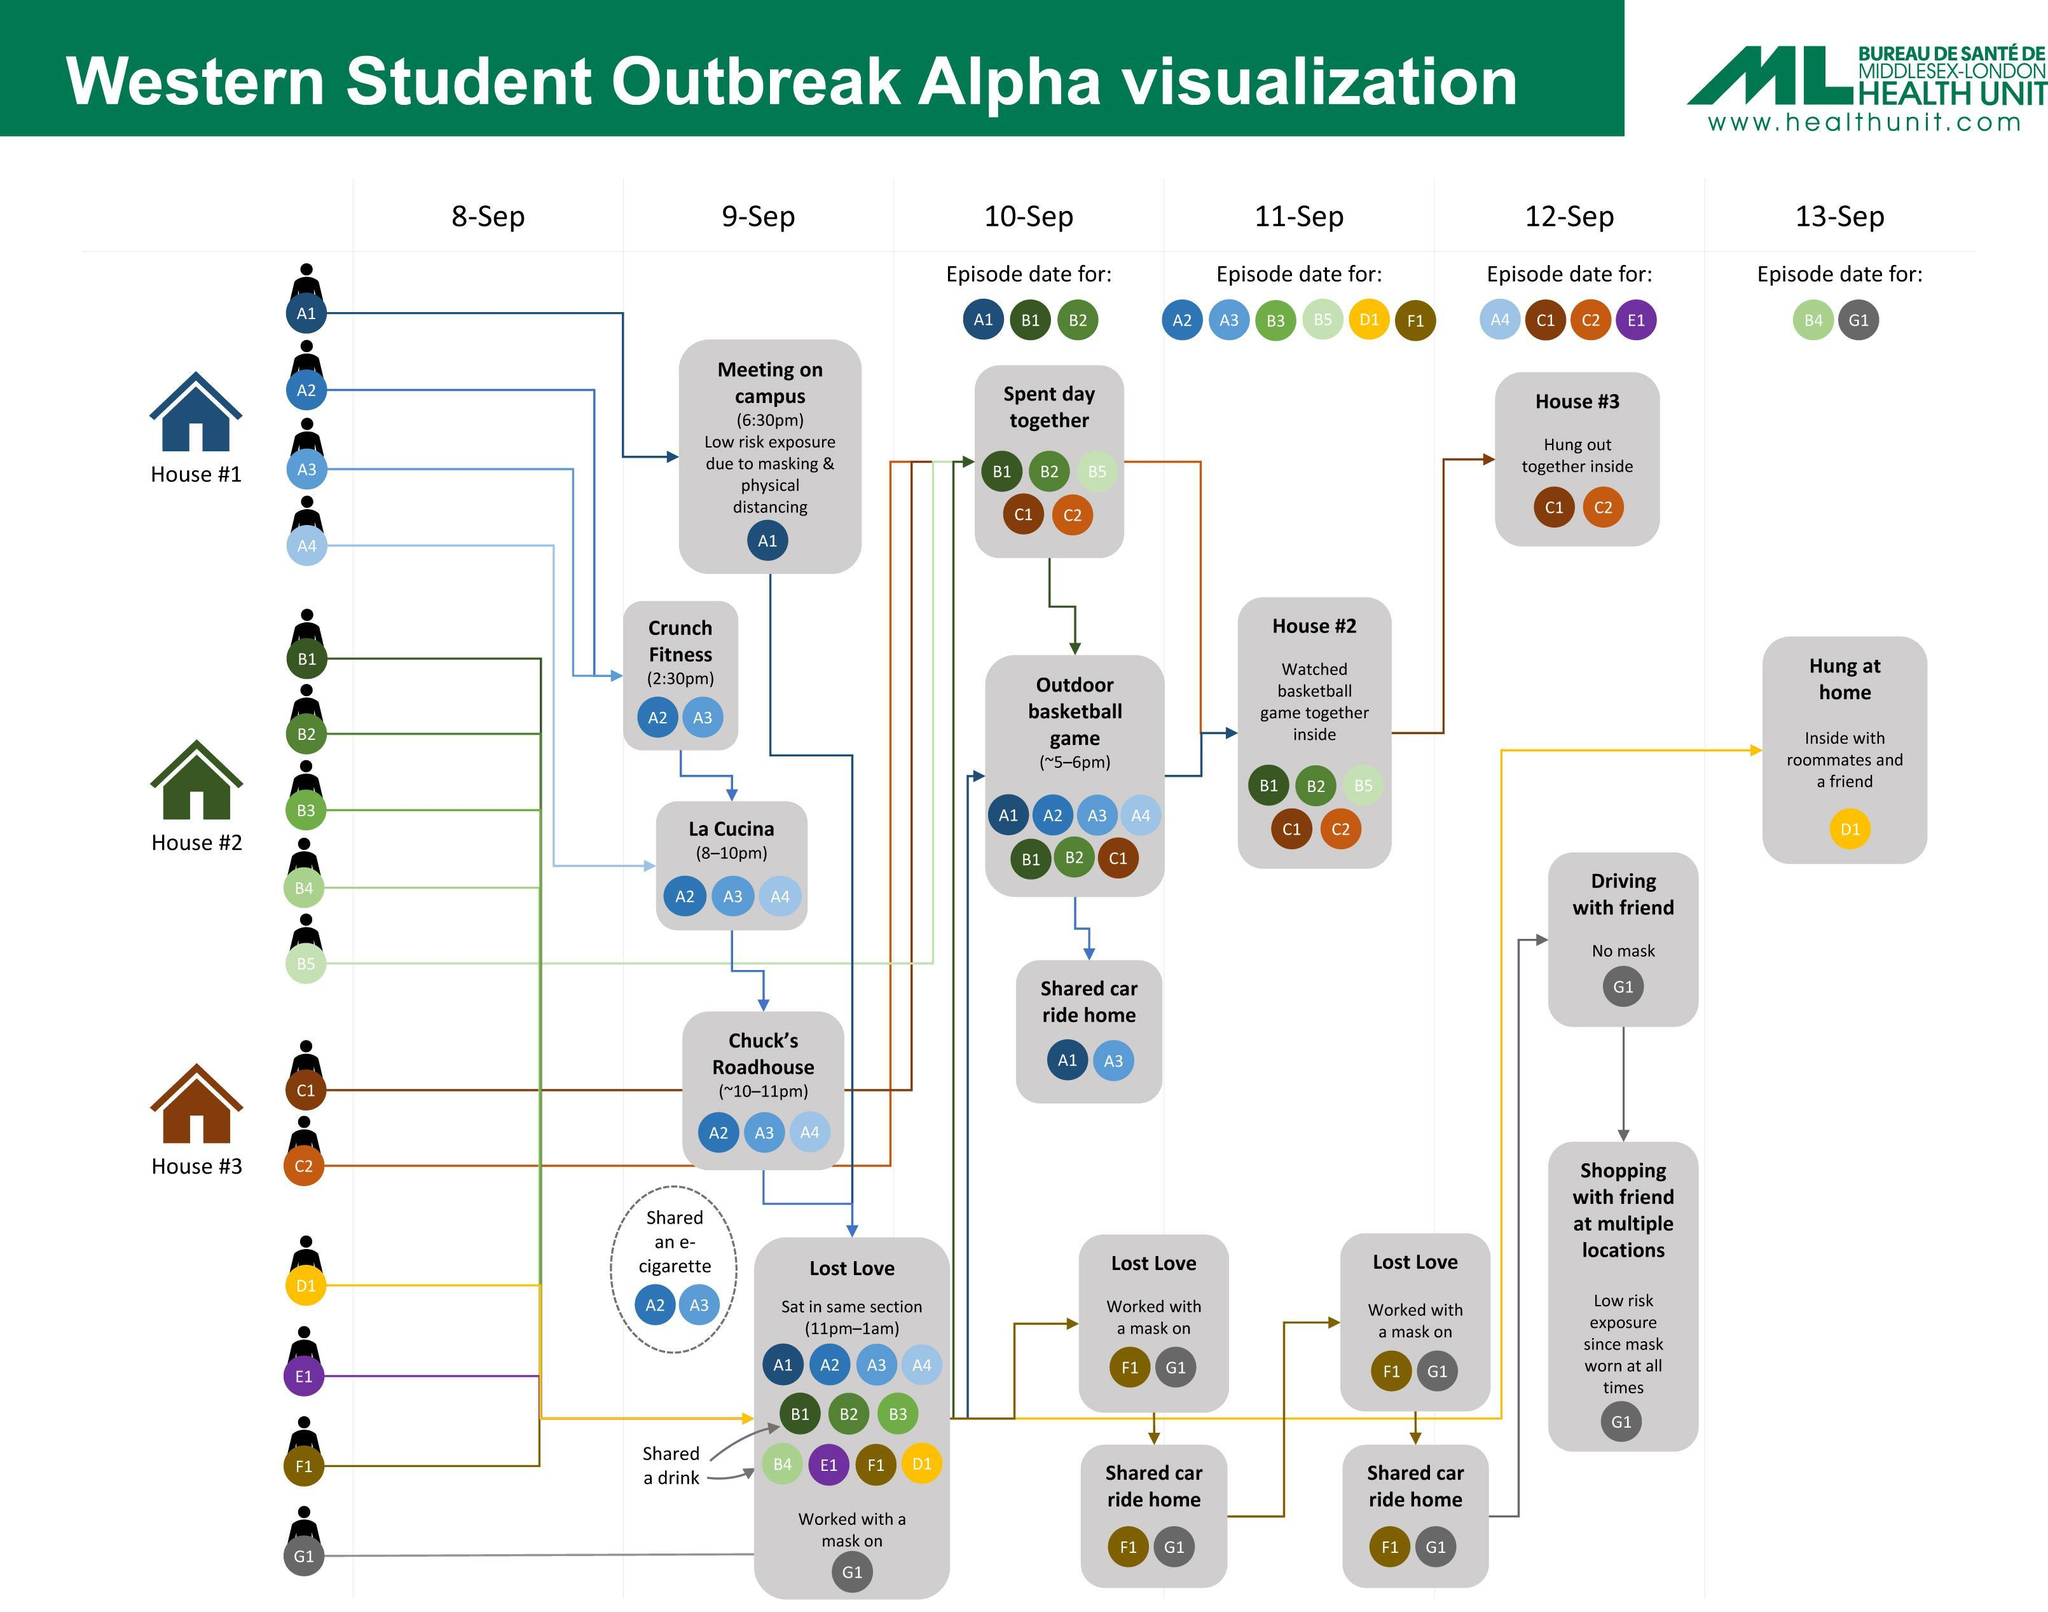Which are the people who were there for La Cucina?
Answer the question with a short phrase. A2, A3, A4 How many people had episode date on 10- Sep? 3 Who all were there in Chuck's Roadhouse? A2, A3, A4 Which people had episode date on 13-Sep? B4, G1 When was the episode date for A1, B1, B2? 10-Sep What is the color code given to the person D1- green, red, white, yellow? yellow With whom B4 shared a drink? B1 